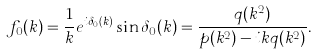<formula> <loc_0><loc_0><loc_500><loc_500>f _ { 0 } ( k ) = \frac { 1 } { k } e ^ { i \delta _ { 0 } ( k ) } \sin \delta _ { 0 } ( k ) = \frac { q ( k ^ { 2 } ) } { p ( k ^ { 2 } ) - i k q ( k ^ { 2 } ) } .</formula> 